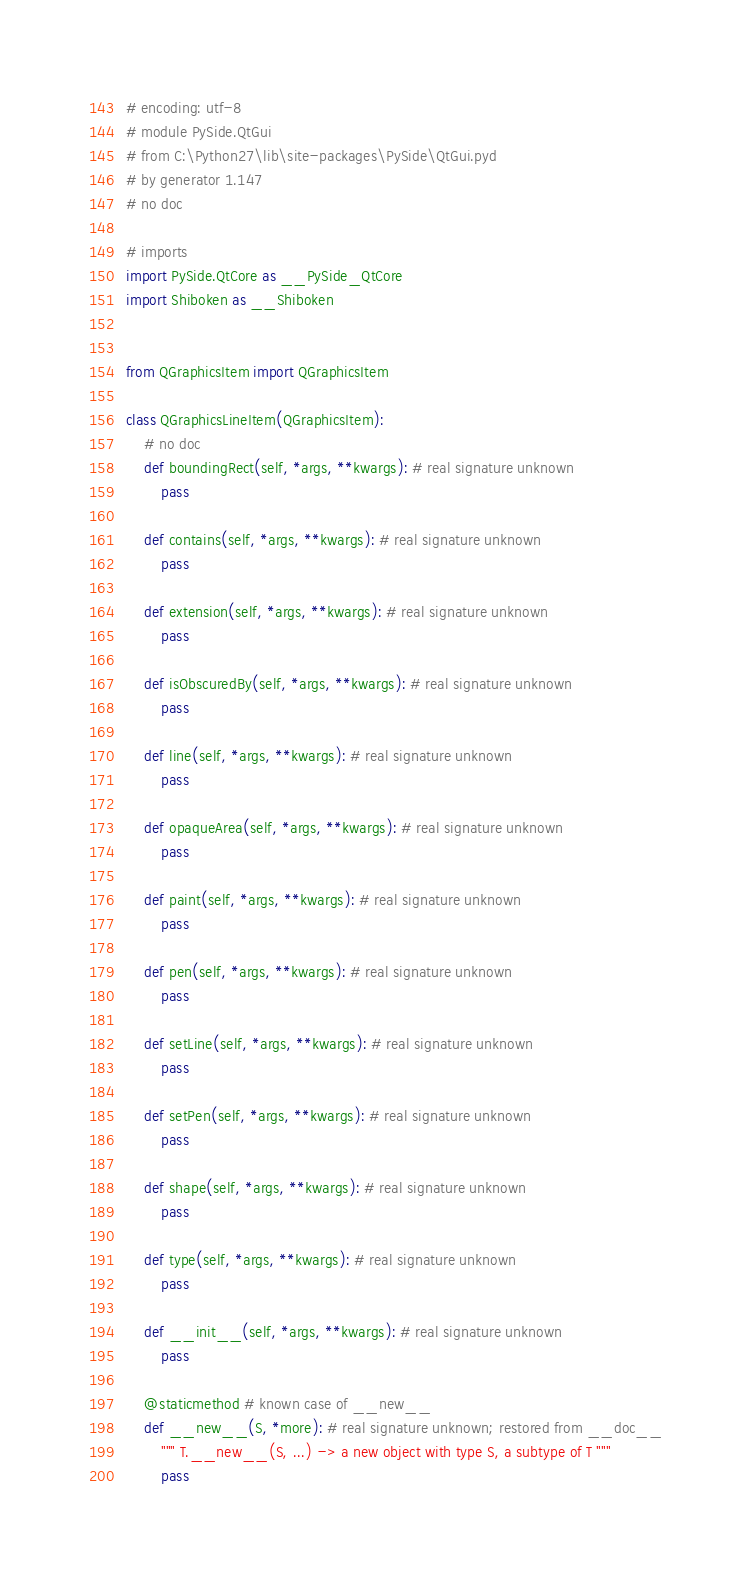Convert code to text. <code><loc_0><loc_0><loc_500><loc_500><_Python_># encoding: utf-8
# module PySide.QtGui
# from C:\Python27\lib\site-packages\PySide\QtGui.pyd
# by generator 1.147
# no doc

# imports
import PySide.QtCore as __PySide_QtCore
import Shiboken as __Shiboken


from QGraphicsItem import QGraphicsItem

class QGraphicsLineItem(QGraphicsItem):
    # no doc
    def boundingRect(self, *args, **kwargs): # real signature unknown
        pass

    def contains(self, *args, **kwargs): # real signature unknown
        pass

    def extension(self, *args, **kwargs): # real signature unknown
        pass

    def isObscuredBy(self, *args, **kwargs): # real signature unknown
        pass

    def line(self, *args, **kwargs): # real signature unknown
        pass

    def opaqueArea(self, *args, **kwargs): # real signature unknown
        pass

    def paint(self, *args, **kwargs): # real signature unknown
        pass

    def pen(self, *args, **kwargs): # real signature unknown
        pass

    def setLine(self, *args, **kwargs): # real signature unknown
        pass

    def setPen(self, *args, **kwargs): # real signature unknown
        pass

    def shape(self, *args, **kwargs): # real signature unknown
        pass

    def type(self, *args, **kwargs): # real signature unknown
        pass

    def __init__(self, *args, **kwargs): # real signature unknown
        pass

    @staticmethod # known case of __new__
    def __new__(S, *more): # real signature unknown; restored from __doc__
        """ T.__new__(S, ...) -> a new object with type S, a subtype of T """
        pass


</code> 